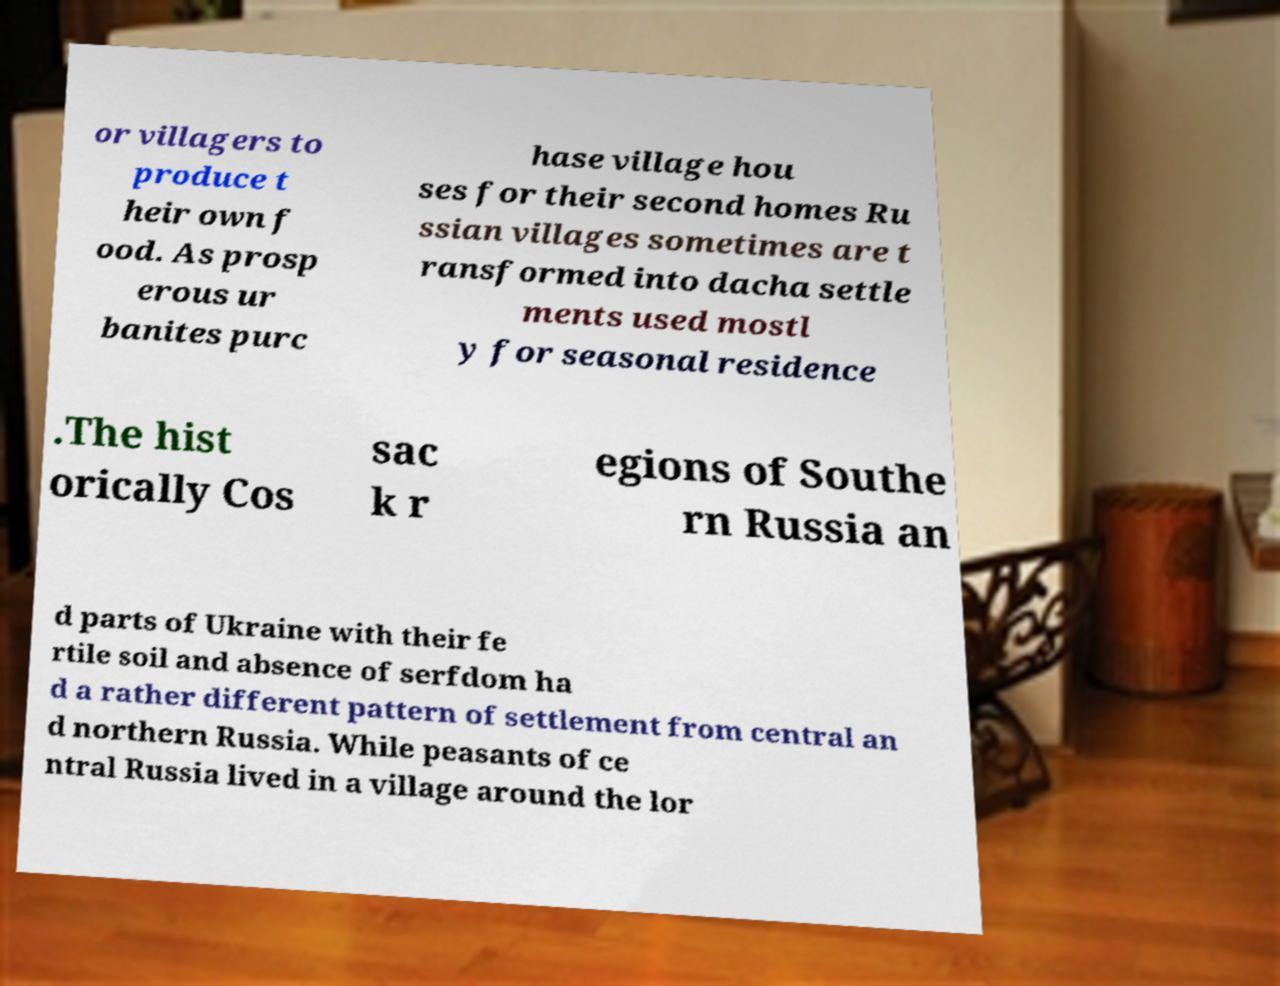I need the written content from this picture converted into text. Can you do that? or villagers to produce t heir own f ood. As prosp erous ur banites purc hase village hou ses for their second homes Ru ssian villages sometimes are t ransformed into dacha settle ments used mostl y for seasonal residence .The hist orically Cos sac k r egions of Southe rn Russia an d parts of Ukraine with their fe rtile soil and absence of serfdom ha d a rather different pattern of settlement from central an d northern Russia. While peasants of ce ntral Russia lived in a village around the lor 